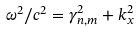Convert formula to latex. <formula><loc_0><loc_0><loc_500><loc_500>\omega ^ { 2 } / c ^ { 2 } = \gamma _ { n , m } ^ { 2 } + k _ { x } ^ { 2 }</formula> 